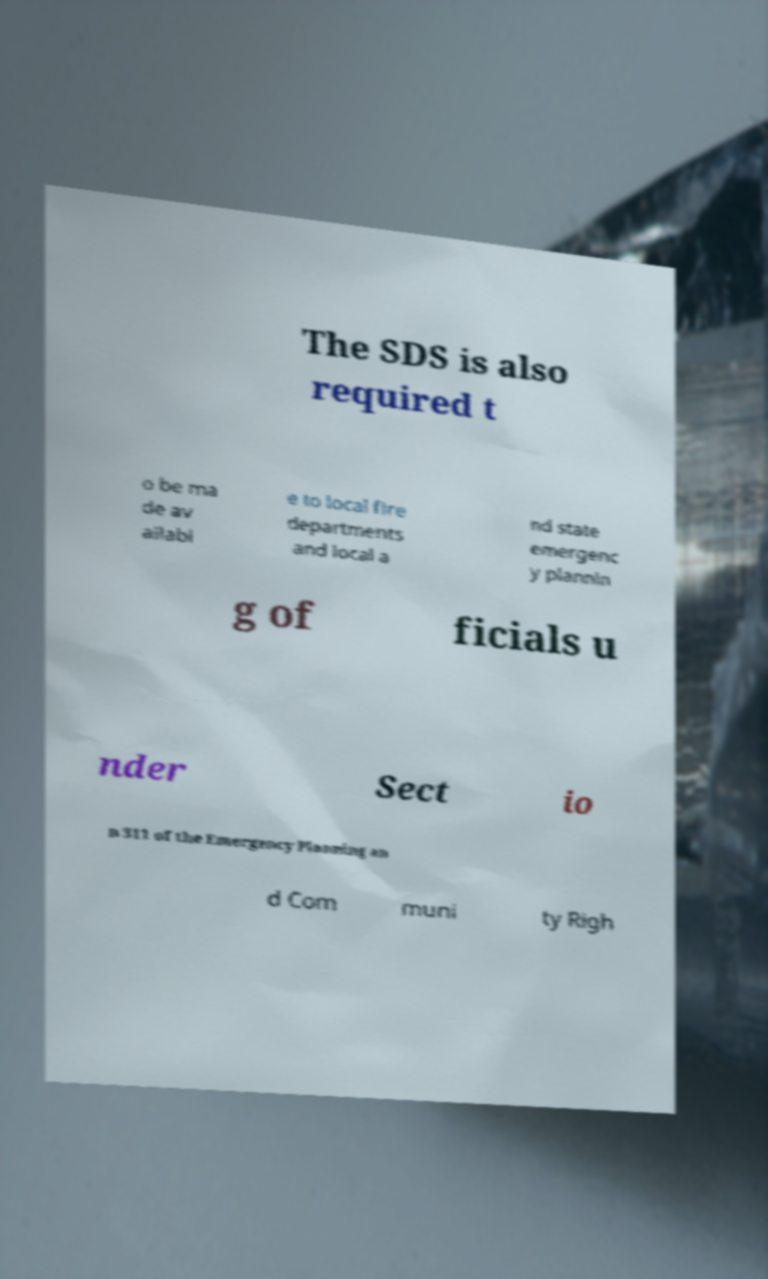Can you read and provide the text displayed in the image?This photo seems to have some interesting text. Can you extract and type it out for me? The SDS is also required t o be ma de av ailabl e to local fire departments and local a nd state emergenc y plannin g of ficials u nder Sect io n 311 of the Emergency Planning an d Com muni ty Righ 